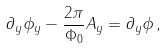<formula> <loc_0><loc_0><loc_500><loc_500>\partial _ { y } \phi _ { y } - \frac { 2 \pi } { \Phi _ { 0 } } A _ { y } = \partial _ { y } \phi \, ,</formula> 